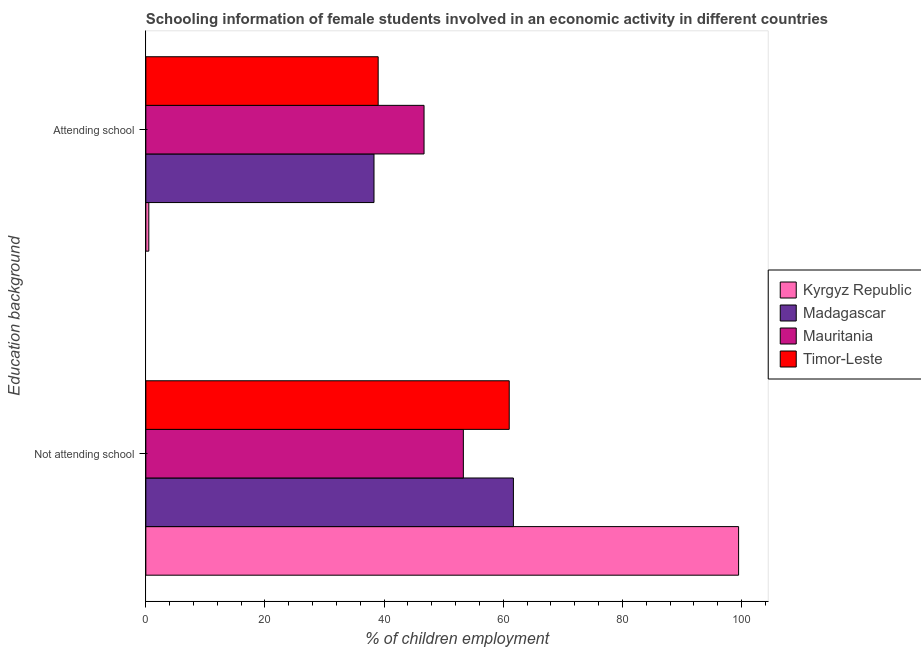How many different coloured bars are there?
Your answer should be very brief. 4. Are the number of bars per tick equal to the number of legend labels?
Your answer should be very brief. Yes. Are the number of bars on each tick of the Y-axis equal?
Your answer should be very brief. Yes. How many bars are there on the 2nd tick from the bottom?
Your answer should be very brief. 4. What is the label of the 1st group of bars from the top?
Offer a very short reply. Attending school. Across all countries, what is the maximum percentage of employed females who are attending school?
Provide a succinct answer. 46.7. Across all countries, what is the minimum percentage of employed females who are not attending school?
Provide a succinct answer. 53.3. In which country was the percentage of employed females who are attending school maximum?
Your answer should be compact. Mauritania. In which country was the percentage of employed females who are not attending school minimum?
Offer a terse response. Mauritania. What is the total percentage of employed females who are attending school in the graph?
Keep it short and to the point. 124.5. What is the difference between the percentage of employed females who are attending school in Mauritania and that in Kyrgyz Republic?
Provide a short and direct response. 46.2. What is the difference between the percentage of employed females who are not attending school in Mauritania and the percentage of employed females who are attending school in Timor-Leste?
Provide a succinct answer. 14.3. What is the average percentage of employed females who are not attending school per country?
Ensure brevity in your answer.  68.88. What is the difference between the percentage of employed females who are not attending school and percentage of employed females who are attending school in Madagascar?
Your answer should be very brief. 23.4. What is the ratio of the percentage of employed females who are not attending school in Kyrgyz Republic to that in Timor-Leste?
Keep it short and to the point. 1.63. Is the percentage of employed females who are attending school in Madagascar less than that in Timor-Leste?
Your answer should be compact. Yes. What does the 2nd bar from the top in Attending school represents?
Make the answer very short. Mauritania. What does the 4th bar from the bottom in Not attending school represents?
Your answer should be very brief. Timor-Leste. How many bars are there?
Your response must be concise. 8. Are all the bars in the graph horizontal?
Your response must be concise. Yes. Are the values on the major ticks of X-axis written in scientific E-notation?
Provide a succinct answer. No. How many legend labels are there?
Your answer should be very brief. 4. How are the legend labels stacked?
Provide a succinct answer. Vertical. What is the title of the graph?
Give a very brief answer. Schooling information of female students involved in an economic activity in different countries. What is the label or title of the X-axis?
Your response must be concise. % of children employment. What is the label or title of the Y-axis?
Give a very brief answer. Education background. What is the % of children employment of Kyrgyz Republic in Not attending school?
Give a very brief answer. 99.5. What is the % of children employment of Madagascar in Not attending school?
Offer a terse response. 61.7. What is the % of children employment in Mauritania in Not attending school?
Offer a very short reply. 53.3. What is the % of children employment in Timor-Leste in Not attending school?
Offer a very short reply. 61. What is the % of children employment of Kyrgyz Republic in Attending school?
Make the answer very short. 0.5. What is the % of children employment of Madagascar in Attending school?
Give a very brief answer. 38.3. What is the % of children employment in Mauritania in Attending school?
Provide a short and direct response. 46.7. Across all Education background, what is the maximum % of children employment in Kyrgyz Republic?
Your answer should be compact. 99.5. Across all Education background, what is the maximum % of children employment in Madagascar?
Give a very brief answer. 61.7. Across all Education background, what is the maximum % of children employment in Mauritania?
Your response must be concise. 53.3. Across all Education background, what is the minimum % of children employment of Kyrgyz Republic?
Offer a very short reply. 0.5. Across all Education background, what is the minimum % of children employment of Madagascar?
Your answer should be very brief. 38.3. Across all Education background, what is the minimum % of children employment in Mauritania?
Provide a succinct answer. 46.7. What is the total % of children employment of Kyrgyz Republic in the graph?
Make the answer very short. 100. What is the total % of children employment in Madagascar in the graph?
Offer a very short reply. 100. What is the total % of children employment in Mauritania in the graph?
Offer a terse response. 100. What is the difference between the % of children employment in Kyrgyz Republic in Not attending school and that in Attending school?
Keep it short and to the point. 99. What is the difference between the % of children employment of Madagascar in Not attending school and that in Attending school?
Keep it short and to the point. 23.4. What is the difference between the % of children employment of Timor-Leste in Not attending school and that in Attending school?
Make the answer very short. 22. What is the difference between the % of children employment of Kyrgyz Republic in Not attending school and the % of children employment of Madagascar in Attending school?
Keep it short and to the point. 61.2. What is the difference between the % of children employment in Kyrgyz Republic in Not attending school and the % of children employment in Mauritania in Attending school?
Your answer should be compact. 52.8. What is the difference between the % of children employment of Kyrgyz Republic in Not attending school and the % of children employment of Timor-Leste in Attending school?
Your response must be concise. 60.5. What is the difference between the % of children employment of Madagascar in Not attending school and the % of children employment of Timor-Leste in Attending school?
Provide a short and direct response. 22.7. What is the average % of children employment of Kyrgyz Republic per Education background?
Offer a terse response. 50. What is the average % of children employment of Timor-Leste per Education background?
Your answer should be very brief. 50. What is the difference between the % of children employment of Kyrgyz Republic and % of children employment of Madagascar in Not attending school?
Provide a succinct answer. 37.8. What is the difference between the % of children employment of Kyrgyz Republic and % of children employment of Mauritania in Not attending school?
Your answer should be very brief. 46.2. What is the difference between the % of children employment of Kyrgyz Republic and % of children employment of Timor-Leste in Not attending school?
Provide a succinct answer. 38.5. What is the difference between the % of children employment in Madagascar and % of children employment in Mauritania in Not attending school?
Keep it short and to the point. 8.4. What is the difference between the % of children employment of Kyrgyz Republic and % of children employment of Madagascar in Attending school?
Provide a succinct answer. -37.8. What is the difference between the % of children employment in Kyrgyz Republic and % of children employment in Mauritania in Attending school?
Ensure brevity in your answer.  -46.2. What is the difference between the % of children employment in Kyrgyz Republic and % of children employment in Timor-Leste in Attending school?
Give a very brief answer. -38.5. What is the difference between the % of children employment of Madagascar and % of children employment of Mauritania in Attending school?
Provide a succinct answer. -8.4. What is the difference between the % of children employment in Mauritania and % of children employment in Timor-Leste in Attending school?
Offer a terse response. 7.7. What is the ratio of the % of children employment in Kyrgyz Republic in Not attending school to that in Attending school?
Offer a very short reply. 199. What is the ratio of the % of children employment of Madagascar in Not attending school to that in Attending school?
Offer a terse response. 1.61. What is the ratio of the % of children employment in Mauritania in Not attending school to that in Attending school?
Make the answer very short. 1.14. What is the ratio of the % of children employment of Timor-Leste in Not attending school to that in Attending school?
Your answer should be very brief. 1.56. What is the difference between the highest and the second highest % of children employment of Madagascar?
Offer a terse response. 23.4. What is the difference between the highest and the second highest % of children employment in Timor-Leste?
Your answer should be compact. 22. What is the difference between the highest and the lowest % of children employment of Madagascar?
Provide a short and direct response. 23.4. What is the difference between the highest and the lowest % of children employment in Mauritania?
Provide a succinct answer. 6.6. What is the difference between the highest and the lowest % of children employment in Timor-Leste?
Make the answer very short. 22. 